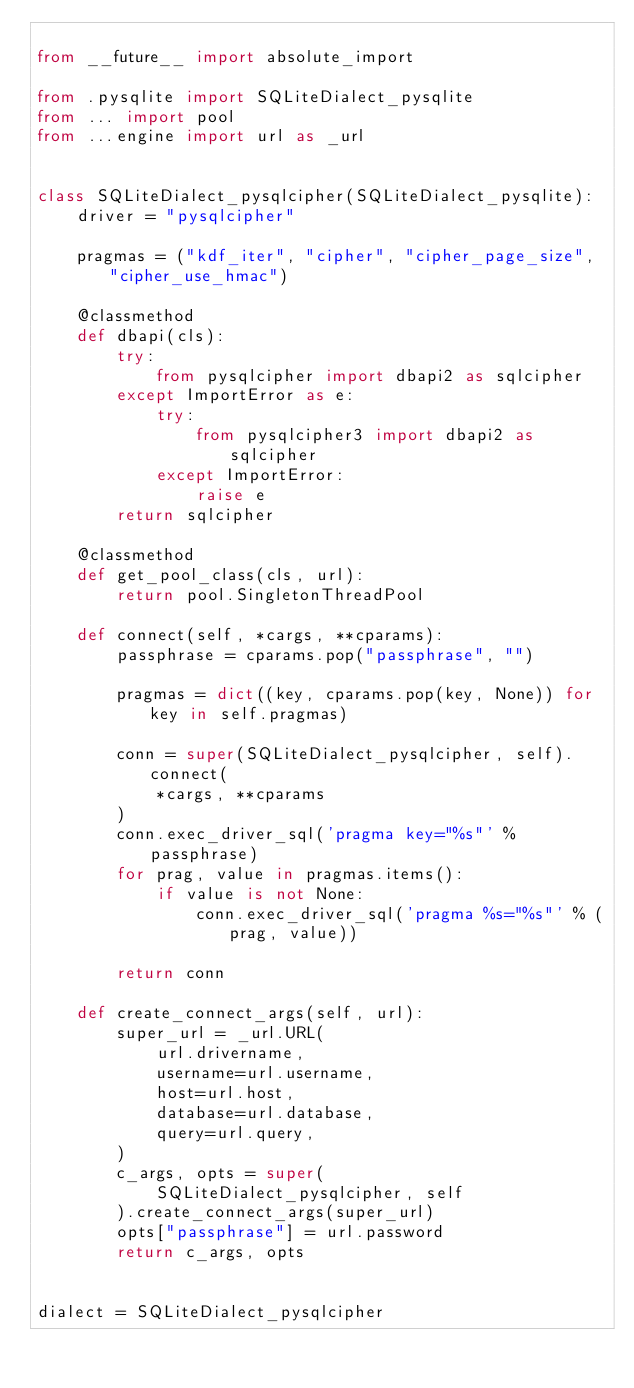<code> <loc_0><loc_0><loc_500><loc_500><_Python_>
from __future__ import absolute_import

from .pysqlite import SQLiteDialect_pysqlite
from ... import pool
from ...engine import url as _url


class SQLiteDialect_pysqlcipher(SQLiteDialect_pysqlite):
    driver = "pysqlcipher"

    pragmas = ("kdf_iter", "cipher", "cipher_page_size", "cipher_use_hmac")

    @classmethod
    def dbapi(cls):
        try:
            from pysqlcipher import dbapi2 as sqlcipher
        except ImportError as e:
            try:
                from pysqlcipher3 import dbapi2 as sqlcipher
            except ImportError:
                raise e
        return sqlcipher

    @classmethod
    def get_pool_class(cls, url):
        return pool.SingletonThreadPool

    def connect(self, *cargs, **cparams):
        passphrase = cparams.pop("passphrase", "")

        pragmas = dict((key, cparams.pop(key, None)) for key in self.pragmas)

        conn = super(SQLiteDialect_pysqlcipher, self).connect(
            *cargs, **cparams
        )
        conn.exec_driver_sql('pragma key="%s"' % passphrase)
        for prag, value in pragmas.items():
            if value is not None:
                conn.exec_driver_sql('pragma %s="%s"' % (prag, value))

        return conn

    def create_connect_args(self, url):
        super_url = _url.URL(
            url.drivername,
            username=url.username,
            host=url.host,
            database=url.database,
            query=url.query,
        )
        c_args, opts = super(
            SQLiteDialect_pysqlcipher, self
        ).create_connect_args(super_url)
        opts["passphrase"] = url.password
        return c_args, opts


dialect = SQLiteDialect_pysqlcipher
</code> 